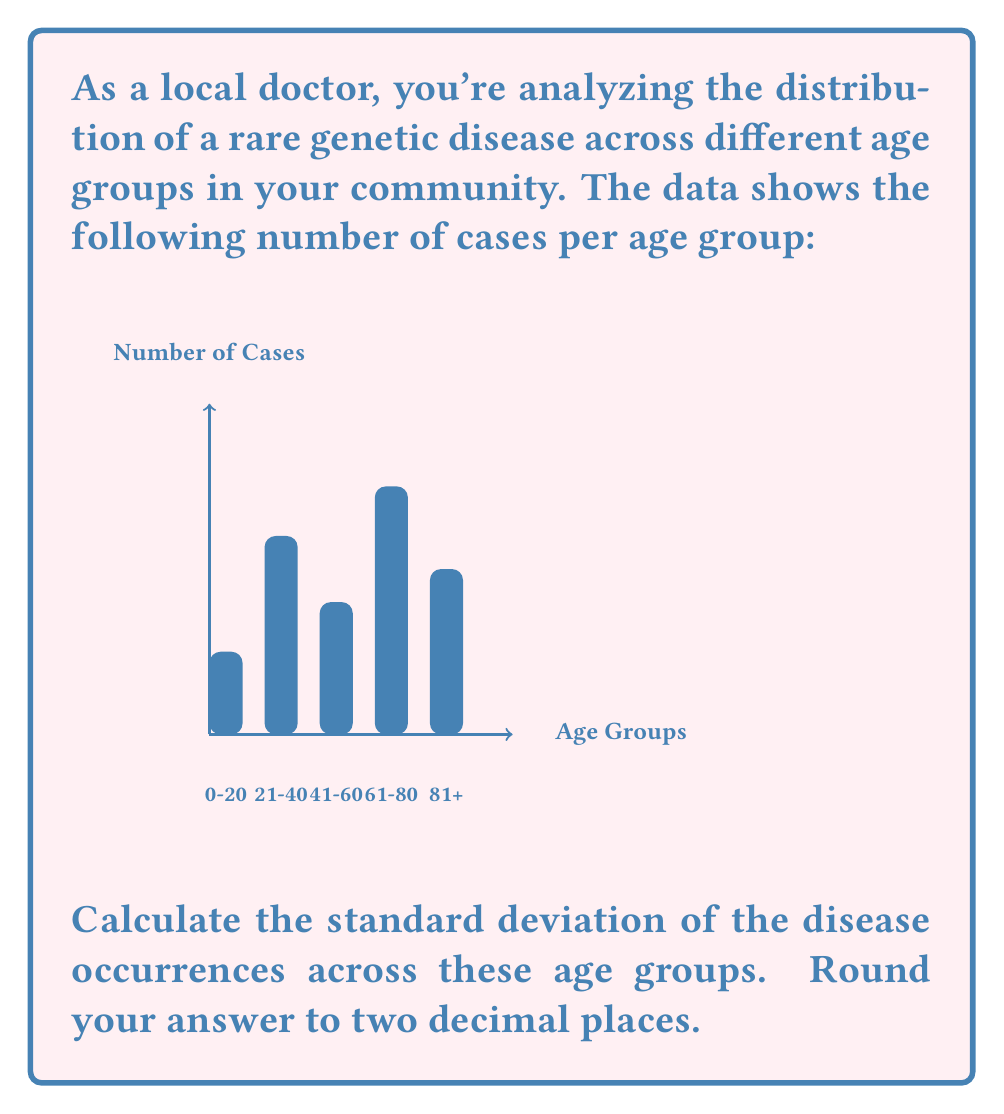Provide a solution to this math problem. To calculate the standard deviation, we'll follow these steps:

1) First, calculate the mean (average) of the data:
   $\bar{x} = \frac{5 + 12 + 8 + 15 + 10}{5} = \frac{50}{5} = 10$

2) Calculate the squared differences from the mean:
   $(5 - 10)^2 = (-5)^2 = 25$
   $(12 - 10)^2 = 2^2 = 4$
   $(8 - 10)^2 = (-2)^2 = 4$
   $(15 - 10)^2 = 5^2 = 25$
   $(10 - 10)^2 = 0^2 = 0$

3) Find the average of these squared differences:
   $\frac{25 + 4 + 4 + 25 + 0}{5} = \frac{58}{5} = 11.6$

4) Take the square root of this value:
   $\sqrt{11.6} \approx 3.4056$

5) Round to two decimal places:
   $3.41$

The formula for standard deviation is:

$$s = \sqrt{\frac{\sum_{i=1}^{n} (x_i - \bar{x})^2}{n}}$$

Where $s$ is the standard deviation, $x_i$ are the individual values, $\bar{x}$ is the mean, and $n$ is the number of values.
Answer: $3.41$ 